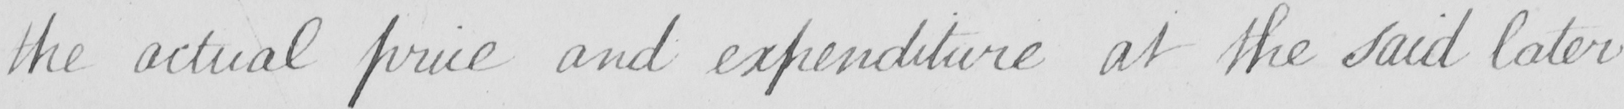Please provide the text content of this handwritten line. the actual price and expenditure at the said later 